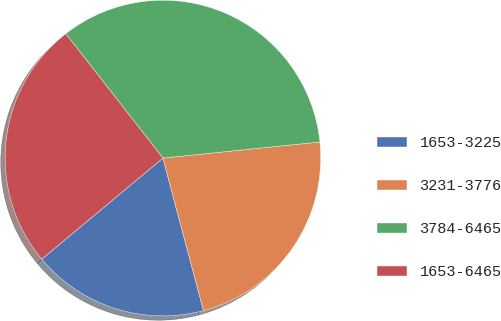Convert chart. <chart><loc_0><loc_0><loc_500><loc_500><pie_chart><fcel>1653-3225<fcel>3231-3776<fcel>3784-6465<fcel>1653-6465<nl><fcel>18.07%<fcel>22.49%<fcel>33.93%<fcel>25.51%<nl></chart> 